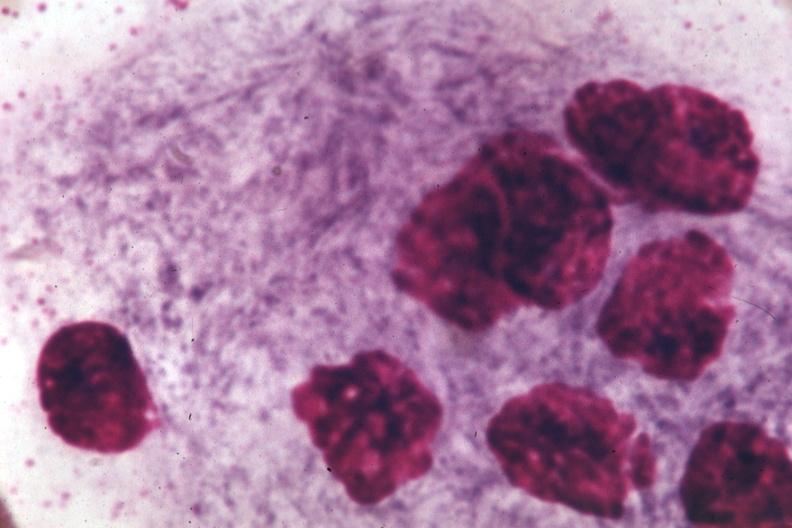s adenoma present?
Answer the question using a single word or phrase. No 